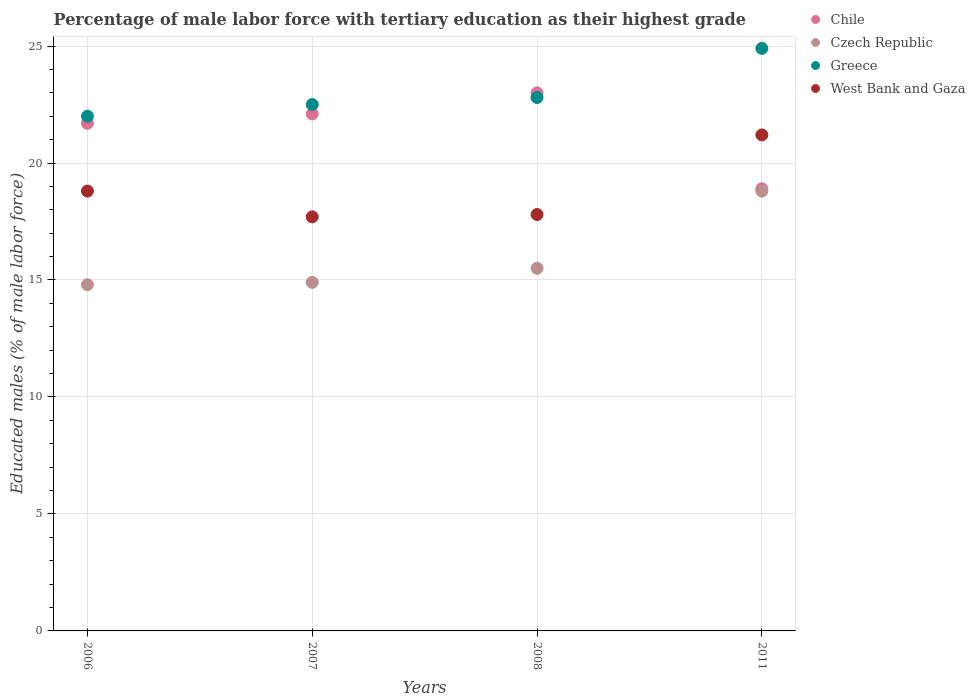Is the number of dotlines equal to the number of legend labels?
Make the answer very short. Yes. What is the percentage of male labor force with tertiary education in Chile in 2007?
Offer a very short reply. 22.1. Across all years, what is the maximum percentage of male labor force with tertiary education in West Bank and Gaza?
Your answer should be compact. 21.2. In which year was the percentage of male labor force with tertiary education in Greece minimum?
Your answer should be very brief. 2006. What is the total percentage of male labor force with tertiary education in Czech Republic in the graph?
Offer a very short reply. 64. What is the difference between the percentage of male labor force with tertiary education in Czech Republic in 2007 and that in 2008?
Provide a succinct answer. -0.6. What is the difference between the percentage of male labor force with tertiary education in West Bank and Gaza in 2006 and the percentage of male labor force with tertiary education in Chile in 2011?
Your answer should be very brief. -0.1. What is the average percentage of male labor force with tertiary education in Greece per year?
Your answer should be compact. 23.05. In the year 2008, what is the difference between the percentage of male labor force with tertiary education in Chile and percentage of male labor force with tertiary education in West Bank and Gaza?
Offer a very short reply. 5.2. What is the ratio of the percentage of male labor force with tertiary education in Czech Republic in 2008 to that in 2011?
Make the answer very short. 0.82. Is the percentage of male labor force with tertiary education in West Bank and Gaza in 2006 less than that in 2011?
Give a very brief answer. Yes. What is the difference between the highest and the second highest percentage of male labor force with tertiary education in Czech Republic?
Provide a succinct answer. 3.3. What is the difference between the highest and the lowest percentage of male labor force with tertiary education in Greece?
Provide a succinct answer. 2.9. In how many years, is the percentage of male labor force with tertiary education in Greece greater than the average percentage of male labor force with tertiary education in Greece taken over all years?
Your answer should be compact. 1. Is the sum of the percentage of male labor force with tertiary education in Greece in 2006 and 2011 greater than the maximum percentage of male labor force with tertiary education in Czech Republic across all years?
Provide a succinct answer. Yes. Is it the case that in every year, the sum of the percentage of male labor force with tertiary education in Czech Republic and percentage of male labor force with tertiary education in West Bank and Gaza  is greater than the sum of percentage of male labor force with tertiary education in Greece and percentage of male labor force with tertiary education in Chile?
Make the answer very short. No. Is the percentage of male labor force with tertiary education in Chile strictly greater than the percentage of male labor force with tertiary education in Czech Republic over the years?
Provide a succinct answer. Yes. Is the percentage of male labor force with tertiary education in Greece strictly less than the percentage of male labor force with tertiary education in West Bank and Gaza over the years?
Offer a terse response. No. What is the difference between two consecutive major ticks on the Y-axis?
Give a very brief answer. 5. Does the graph contain any zero values?
Offer a terse response. No. Where does the legend appear in the graph?
Offer a terse response. Top right. How are the legend labels stacked?
Keep it short and to the point. Vertical. What is the title of the graph?
Your response must be concise. Percentage of male labor force with tertiary education as their highest grade. What is the label or title of the Y-axis?
Provide a short and direct response. Educated males (% of male labor force). What is the Educated males (% of male labor force) of Chile in 2006?
Offer a terse response. 21.7. What is the Educated males (% of male labor force) in Czech Republic in 2006?
Provide a short and direct response. 14.8. What is the Educated males (% of male labor force) in Greece in 2006?
Make the answer very short. 22. What is the Educated males (% of male labor force) of West Bank and Gaza in 2006?
Offer a very short reply. 18.8. What is the Educated males (% of male labor force) of Chile in 2007?
Make the answer very short. 22.1. What is the Educated males (% of male labor force) in Czech Republic in 2007?
Provide a succinct answer. 14.9. What is the Educated males (% of male labor force) in Greece in 2007?
Your response must be concise. 22.5. What is the Educated males (% of male labor force) of West Bank and Gaza in 2007?
Your answer should be very brief. 17.7. What is the Educated males (% of male labor force) in Czech Republic in 2008?
Offer a terse response. 15.5. What is the Educated males (% of male labor force) of Greece in 2008?
Ensure brevity in your answer.  22.8. What is the Educated males (% of male labor force) in West Bank and Gaza in 2008?
Offer a terse response. 17.8. What is the Educated males (% of male labor force) of Chile in 2011?
Keep it short and to the point. 18.9. What is the Educated males (% of male labor force) in Czech Republic in 2011?
Provide a short and direct response. 18.8. What is the Educated males (% of male labor force) in Greece in 2011?
Your answer should be very brief. 24.9. What is the Educated males (% of male labor force) in West Bank and Gaza in 2011?
Your response must be concise. 21.2. Across all years, what is the maximum Educated males (% of male labor force) in Chile?
Your answer should be compact. 23. Across all years, what is the maximum Educated males (% of male labor force) in Czech Republic?
Give a very brief answer. 18.8. Across all years, what is the maximum Educated males (% of male labor force) in Greece?
Ensure brevity in your answer.  24.9. Across all years, what is the maximum Educated males (% of male labor force) in West Bank and Gaza?
Make the answer very short. 21.2. Across all years, what is the minimum Educated males (% of male labor force) of Chile?
Offer a very short reply. 18.9. Across all years, what is the minimum Educated males (% of male labor force) of Czech Republic?
Offer a terse response. 14.8. Across all years, what is the minimum Educated males (% of male labor force) of West Bank and Gaza?
Offer a very short reply. 17.7. What is the total Educated males (% of male labor force) of Chile in the graph?
Your answer should be compact. 85.7. What is the total Educated males (% of male labor force) of Czech Republic in the graph?
Make the answer very short. 64. What is the total Educated males (% of male labor force) in Greece in the graph?
Your answer should be very brief. 92.2. What is the total Educated males (% of male labor force) of West Bank and Gaza in the graph?
Provide a short and direct response. 75.5. What is the difference between the Educated males (% of male labor force) in Greece in 2006 and that in 2007?
Ensure brevity in your answer.  -0.5. What is the difference between the Educated males (% of male labor force) in West Bank and Gaza in 2006 and that in 2007?
Make the answer very short. 1.1. What is the difference between the Educated males (% of male labor force) in Czech Republic in 2006 and that in 2008?
Your answer should be compact. -0.7. What is the difference between the Educated males (% of male labor force) of Greece in 2006 and that in 2008?
Your response must be concise. -0.8. What is the difference between the Educated males (% of male labor force) in Chile in 2006 and that in 2011?
Provide a short and direct response. 2.8. What is the difference between the Educated males (% of male labor force) of Greece in 2006 and that in 2011?
Provide a succinct answer. -2.9. What is the difference between the Educated males (% of male labor force) of West Bank and Gaza in 2006 and that in 2011?
Offer a very short reply. -2.4. What is the difference between the Educated males (% of male labor force) in West Bank and Gaza in 2007 and that in 2008?
Provide a short and direct response. -0.1. What is the difference between the Educated males (% of male labor force) in Chile in 2007 and that in 2011?
Make the answer very short. 3.2. What is the difference between the Educated males (% of male labor force) of Greece in 2007 and that in 2011?
Provide a succinct answer. -2.4. What is the difference between the Educated males (% of male labor force) in Czech Republic in 2008 and that in 2011?
Your answer should be compact. -3.3. What is the difference between the Educated males (% of male labor force) of Chile in 2006 and the Educated males (% of male labor force) of West Bank and Gaza in 2007?
Give a very brief answer. 4. What is the difference between the Educated males (% of male labor force) in Czech Republic in 2006 and the Educated males (% of male labor force) in Greece in 2007?
Your answer should be very brief. -7.7. What is the difference between the Educated males (% of male labor force) in Czech Republic in 2006 and the Educated males (% of male labor force) in West Bank and Gaza in 2007?
Provide a short and direct response. -2.9. What is the difference between the Educated males (% of male labor force) of Chile in 2006 and the Educated males (% of male labor force) of West Bank and Gaza in 2008?
Provide a short and direct response. 3.9. What is the difference between the Educated males (% of male labor force) in Czech Republic in 2006 and the Educated males (% of male labor force) in Greece in 2008?
Your answer should be compact. -8. What is the difference between the Educated males (% of male labor force) of Czech Republic in 2006 and the Educated males (% of male labor force) of Greece in 2011?
Provide a short and direct response. -10.1. What is the difference between the Educated males (% of male labor force) in Czech Republic in 2006 and the Educated males (% of male labor force) in West Bank and Gaza in 2011?
Your answer should be compact. -6.4. What is the difference between the Educated males (% of male labor force) of Chile in 2007 and the Educated males (% of male labor force) of Czech Republic in 2008?
Your response must be concise. 6.6. What is the difference between the Educated males (% of male labor force) of Czech Republic in 2007 and the Educated males (% of male labor force) of West Bank and Gaza in 2008?
Ensure brevity in your answer.  -2.9. What is the difference between the Educated males (% of male labor force) of Czech Republic in 2007 and the Educated males (% of male labor force) of Greece in 2011?
Ensure brevity in your answer.  -10. What is the difference between the Educated males (% of male labor force) in Greece in 2007 and the Educated males (% of male labor force) in West Bank and Gaza in 2011?
Make the answer very short. 1.3. What is the difference between the Educated males (% of male labor force) in Chile in 2008 and the Educated males (% of male labor force) in Czech Republic in 2011?
Ensure brevity in your answer.  4.2. What is the difference between the Educated males (% of male labor force) in Chile in 2008 and the Educated males (% of male labor force) in Greece in 2011?
Provide a short and direct response. -1.9. What is the difference between the Educated males (% of male labor force) in Czech Republic in 2008 and the Educated males (% of male labor force) in Greece in 2011?
Ensure brevity in your answer.  -9.4. What is the average Educated males (% of male labor force) in Chile per year?
Make the answer very short. 21.43. What is the average Educated males (% of male labor force) of Greece per year?
Provide a short and direct response. 23.05. What is the average Educated males (% of male labor force) in West Bank and Gaza per year?
Your answer should be compact. 18.88. In the year 2006, what is the difference between the Educated males (% of male labor force) in Chile and Educated males (% of male labor force) in Czech Republic?
Your answer should be very brief. 6.9. In the year 2006, what is the difference between the Educated males (% of male labor force) of Chile and Educated males (% of male labor force) of Greece?
Keep it short and to the point. -0.3. In the year 2006, what is the difference between the Educated males (% of male labor force) in Czech Republic and Educated males (% of male labor force) in West Bank and Gaza?
Give a very brief answer. -4. In the year 2006, what is the difference between the Educated males (% of male labor force) of Greece and Educated males (% of male labor force) of West Bank and Gaza?
Offer a very short reply. 3.2. In the year 2007, what is the difference between the Educated males (% of male labor force) of Czech Republic and Educated males (% of male labor force) of West Bank and Gaza?
Offer a very short reply. -2.8. In the year 2008, what is the difference between the Educated males (% of male labor force) in Greece and Educated males (% of male labor force) in West Bank and Gaza?
Your answer should be compact. 5. In the year 2011, what is the difference between the Educated males (% of male labor force) in Chile and Educated males (% of male labor force) in Czech Republic?
Give a very brief answer. 0.1. In the year 2011, what is the difference between the Educated males (% of male labor force) of Chile and Educated males (% of male labor force) of Greece?
Your response must be concise. -6. In the year 2011, what is the difference between the Educated males (% of male labor force) in Czech Republic and Educated males (% of male labor force) in Greece?
Keep it short and to the point. -6.1. In the year 2011, what is the difference between the Educated males (% of male labor force) of Greece and Educated males (% of male labor force) of West Bank and Gaza?
Your answer should be very brief. 3.7. What is the ratio of the Educated males (% of male labor force) in Chile in 2006 to that in 2007?
Ensure brevity in your answer.  0.98. What is the ratio of the Educated males (% of male labor force) in Czech Republic in 2006 to that in 2007?
Ensure brevity in your answer.  0.99. What is the ratio of the Educated males (% of male labor force) in Greece in 2006 to that in 2007?
Ensure brevity in your answer.  0.98. What is the ratio of the Educated males (% of male labor force) of West Bank and Gaza in 2006 to that in 2007?
Offer a very short reply. 1.06. What is the ratio of the Educated males (% of male labor force) of Chile in 2006 to that in 2008?
Keep it short and to the point. 0.94. What is the ratio of the Educated males (% of male labor force) of Czech Republic in 2006 to that in 2008?
Provide a succinct answer. 0.95. What is the ratio of the Educated males (% of male labor force) of Greece in 2006 to that in 2008?
Your answer should be very brief. 0.96. What is the ratio of the Educated males (% of male labor force) of West Bank and Gaza in 2006 to that in 2008?
Keep it short and to the point. 1.06. What is the ratio of the Educated males (% of male labor force) in Chile in 2006 to that in 2011?
Keep it short and to the point. 1.15. What is the ratio of the Educated males (% of male labor force) in Czech Republic in 2006 to that in 2011?
Your response must be concise. 0.79. What is the ratio of the Educated males (% of male labor force) of Greece in 2006 to that in 2011?
Give a very brief answer. 0.88. What is the ratio of the Educated males (% of male labor force) in West Bank and Gaza in 2006 to that in 2011?
Keep it short and to the point. 0.89. What is the ratio of the Educated males (% of male labor force) of Chile in 2007 to that in 2008?
Give a very brief answer. 0.96. What is the ratio of the Educated males (% of male labor force) in Czech Republic in 2007 to that in 2008?
Offer a terse response. 0.96. What is the ratio of the Educated males (% of male labor force) of West Bank and Gaza in 2007 to that in 2008?
Your answer should be very brief. 0.99. What is the ratio of the Educated males (% of male labor force) in Chile in 2007 to that in 2011?
Your response must be concise. 1.17. What is the ratio of the Educated males (% of male labor force) of Czech Republic in 2007 to that in 2011?
Provide a short and direct response. 0.79. What is the ratio of the Educated males (% of male labor force) in Greece in 2007 to that in 2011?
Your response must be concise. 0.9. What is the ratio of the Educated males (% of male labor force) in West Bank and Gaza in 2007 to that in 2011?
Provide a succinct answer. 0.83. What is the ratio of the Educated males (% of male labor force) of Chile in 2008 to that in 2011?
Your answer should be compact. 1.22. What is the ratio of the Educated males (% of male labor force) of Czech Republic in 2008 to that in 2011?
Make the answer very short. 0.82. What is the ratio of the Educated males (% of male labor force) of Greece in 2008 to that in 2011?
Make the answer very short. 0.92. What is the ratio of the Educated males (% of male labor force) of West Bank and Gaza in 2008 to that in 2011?
Offer a terse response. 0.84. What is the difference between the highest and the second highest Educated males (% of male labor force) in Chile?
Offer a terse response. 0.9. What is the difference between the highest and the second highest Educated males (% of male labor force) in Czech Republic?
Provide a succinct answer. 3.3. What is the difference between the highest and the second highest Educated males (% of male labor force) of West Bank and Gaza?
Provide a succinct answer. 2.4. What is the difference between the highest and the lowest Educated males (% of male labor force) in Chile?
Offer a very short reply. 4.1. 